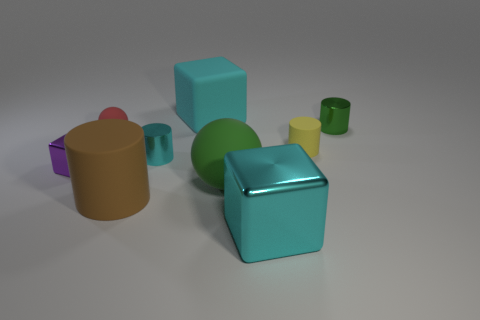Does the big rubber block have the same color as the big cube that is in front of the small cyan metal cylinder?
Your answer should be very brief. Yes. There is a cube that is both in front of the red rubber object and right of the tiny shiny block; what is it made of?
Offer a very short reply. Metal. Is there a block that has the same size as the cyan metallic cylinder?
Offer a terse response. Yes. What is the material of the brown cylinder that is the same size as the green matte thing?
Your response must be concise. Rubber. What number of tiny red things are on the right side of the green rubber thing?
Offer a terse response. 0. There is a metal object that is to the left of the tiny cyan object; is it the same shape as the cyan matte object?
Your answer should be very brief. Yes. Is there a large brown thing of the same shape as the yellow object?
Offer a terse response. Yes. There is a big thing that is the same color as the rubber block; what is its material?
Provide a succinct answer. Metal. The cyan metallic object that is behind the metal cube that is left of the large sphere is what shape?
Ensure brevity in your answer.  Cylinder. How many yellow cylinders are made of the same material as the green ball?
Keep it short and to the point. 1. 